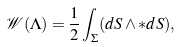<formula> <loc_0><loc_0><loc_500><loc_500>\mathcal { W } ( \Lambda ) = \frac { 1 } { 2 } \int _ { \Sigma } ( d S \wedge * d S ) ,</formula> 